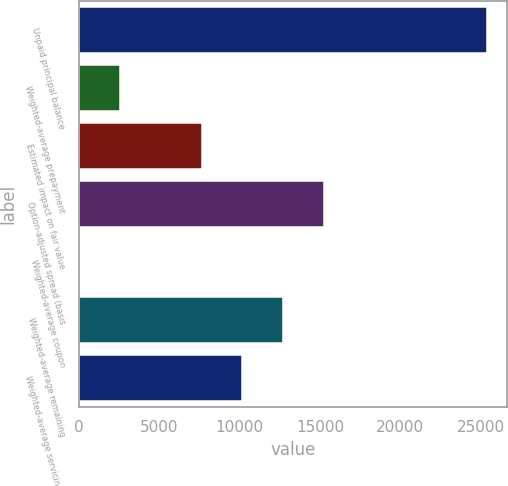Convert chart. <chart><loc_0><loc_0><loc_500><loc_500><bar_chart><fcel>Unpaid principal balance<fcel>Weighted-average prepayment<fcel>Estimated impact on fair value<fcel>Option-adjusted spread (basis<fcel>Weighted-average coupon<fcel>Weighted-average remaining<fcel>Weighted-average servicing fee<nl><fcel>25375<fcel>2542.42<fcel>7616.32<fcel>15227.2<fcel>5.47<fcel>12690.2<fcel>10153.3<nl></chart> 